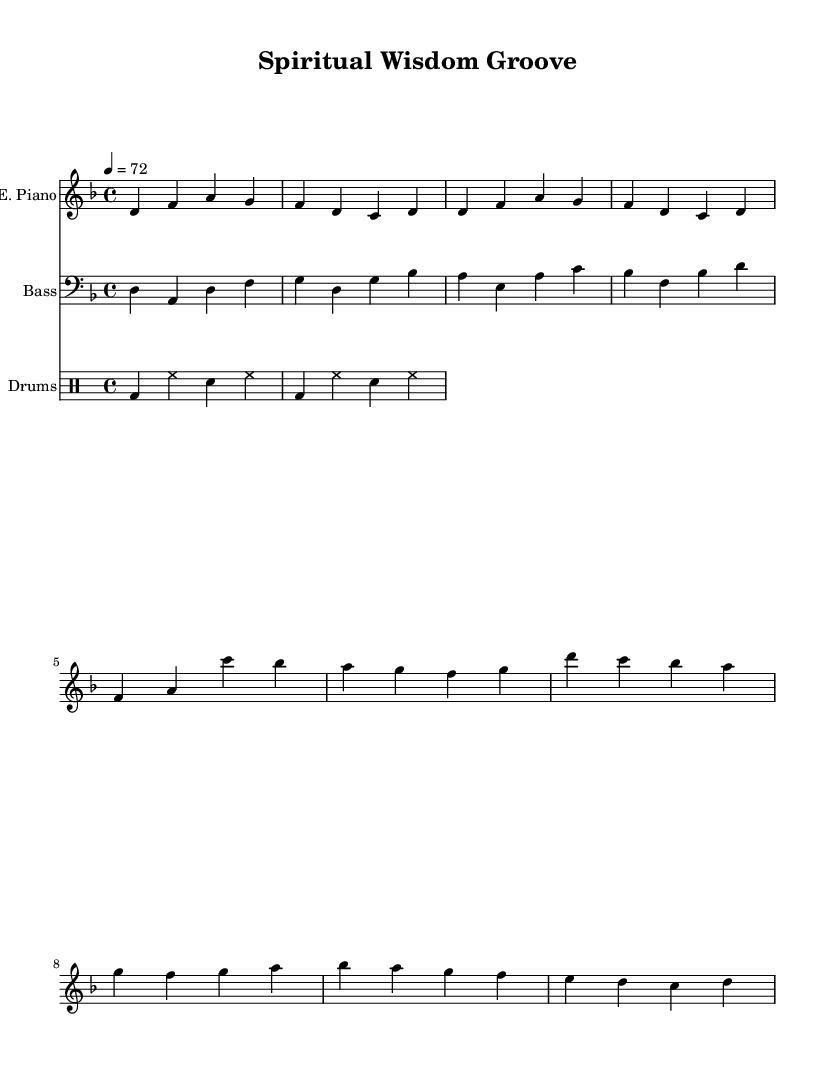What is the key signature of this music? The key signature is D minor, indicated by the presence of one flat (B flat) in the key signature.
Answer: D minor What is the time signature of this piece? The time signature is 4/4, which is indicated at the beginning of the sheet music, specifying four beats per measure.
Answer: 4/4 What is the tempo marking in this score? The tempo is marked at 72 beats per minute, which is indicated at the beginning of the score with the notation "4 = 72".
Answer: 72 How many measures are in the verse section? The verse section contains four measures, as evidenced by the repeated structure in the notated part for the verse.
Answer: Four What instrument plays the bass line? The bass line is written for the bass guitar, which is indicated in the staff labeling at the start of that part.
Answer: Bass guitar What type of drum pattern is used in this piece? The drum pattern utilized is a basic funk pattern, characterized by the use of bass drum and snare with hi-hat, typical in funk music.
Answer: Basic funk pattern How many different instruments are represented in this score? There are three instruments represented in the score: electric piano, bass, and drums, identifiable by their respective staves at the top of the sheet.
Answer: Three 